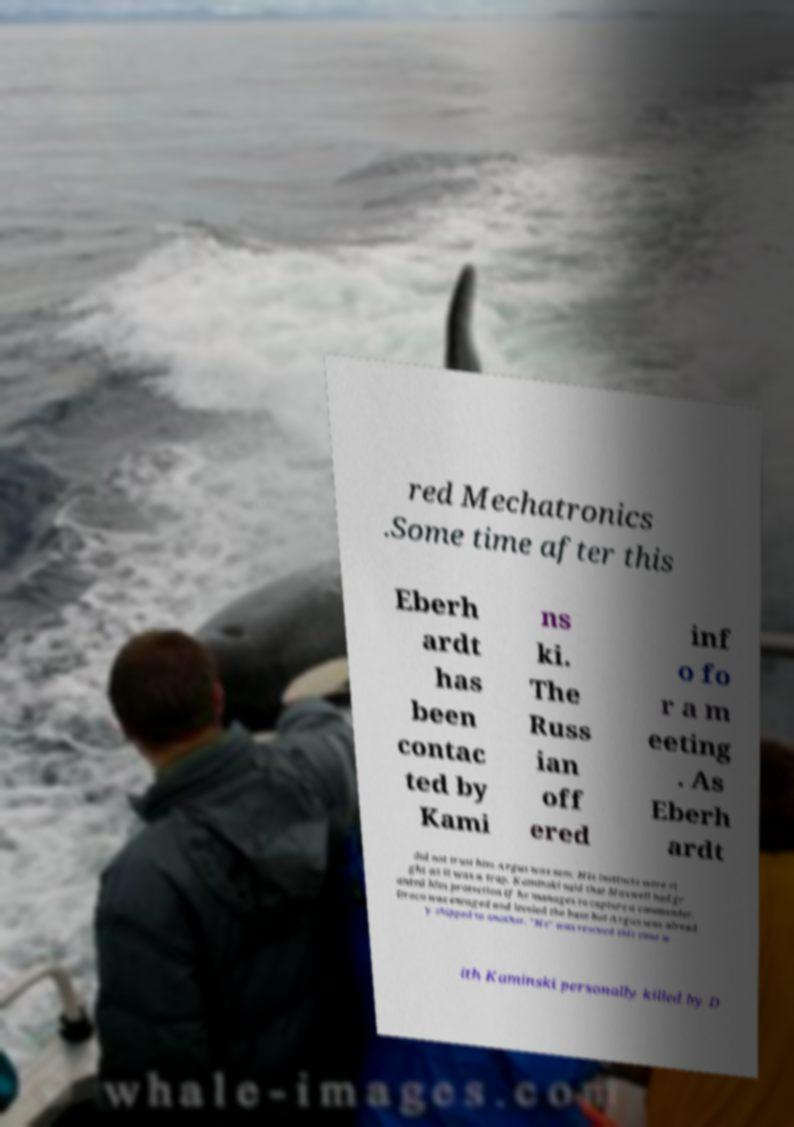What messages or text are displayed in this image? I need them in a readable, typed format. red Mechatronics .Some time after this Eberh ardt has been contac ted by Kami ns ki. The Russ ian off ered inf o fo r a m eeting . As Eberh ardt did not trust him Argus was sent. His instincts were ri ght as it was a trap. Kaminski said that Maxwell had gr anted him protection if he manages to capture a commander. Draco was enraged and leveled the base but Argus was alread y shipped to another. "He" was rescued this time w ith Kaminski personally killed by D 